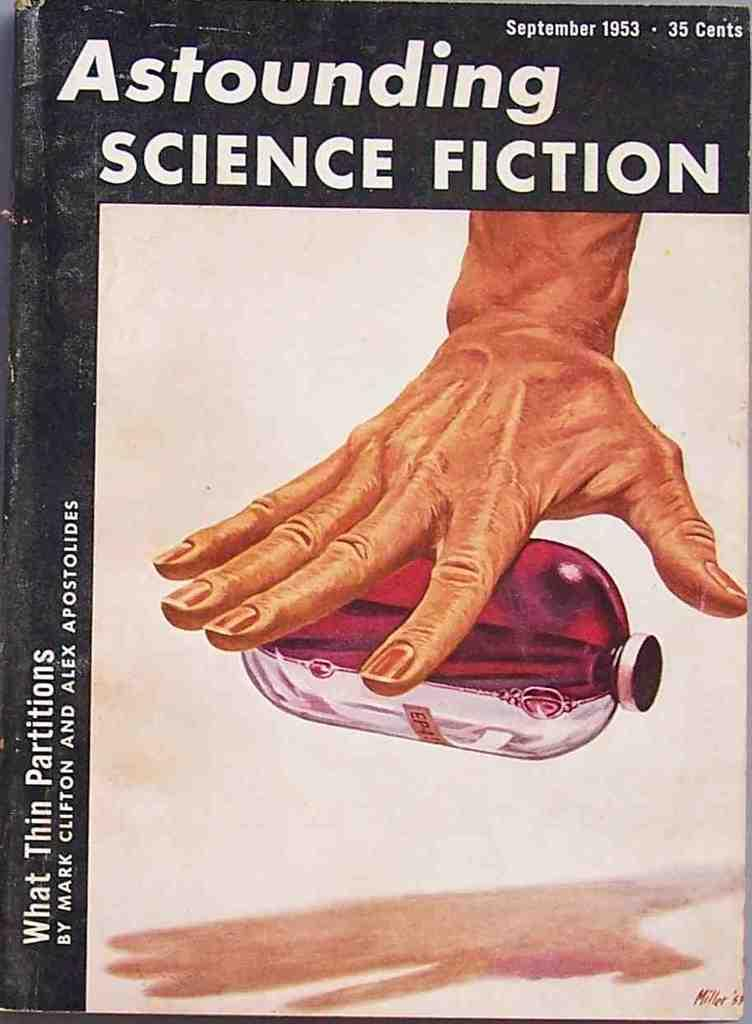<image>
Write a terse but informative summary of the picture. A book cover is dated September 1953 and has a price of 35 cents.. 